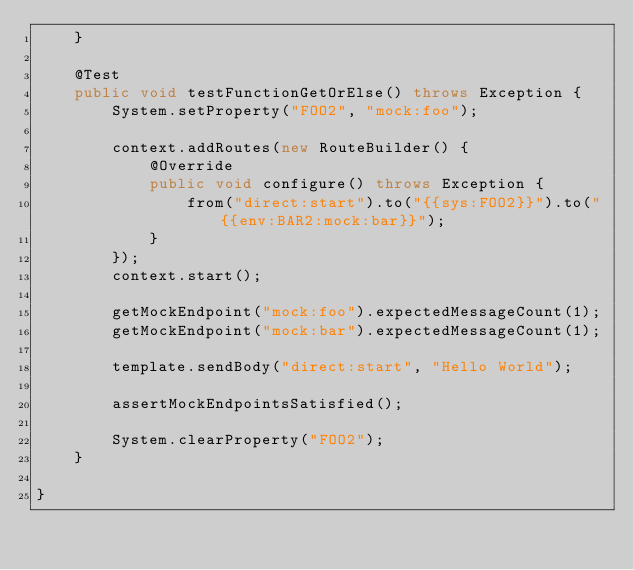Convert code to text. <code><loc_0><loc_0><loc_500><loc_500><_Java_>    }

    @Test
    public void testFunctionGetOrElse() throws Exception {
        System.setProperty("FOO2", "mock:foo");

        context.addRoutes(new RouteBuilder() {
            @Override
            public void configure() throws Exception {
                from("direct:start").to("{{sys:FOO2}}").to("{{env:BAR2:mock:bar}}");
            }
        });
        context.start();

        getMockEndpoint("mock:foo").expectedMessageCount(1);
        getMockEndpoint("mock:bar").expectedMessageCount(1);

        template.sendBody("direct:start", "Hello World");

        assertMockEndpointsSatisfied();

        System.clearProperty("FOO2");
    }

}
</code> 